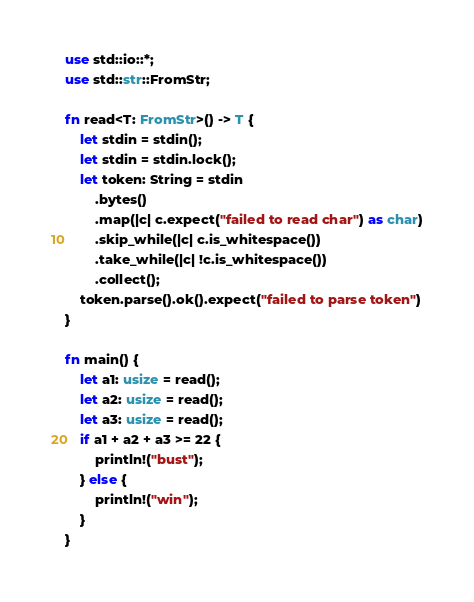Convert code to text. <code><loc_0><loc_0><loc_500><loc_500><_Rust_>use std::io::*;
use std::str::FromStr;

fn read<T: FromStr>() -> T {
    let stdin = stdin();
    let stdin = stdin.lock();
    let token: String = stdin
        .bytes()
        .map(|c| c.expect("failed to read char") as char)
        .skip_while(|c| c.is_whitespace())
        .take_while(|c| !c.is_whitespace())
        .collect();
    token.parse().ok().expect("failed to parse token")
}

fn main() {
    let a1: usize = read();
    let a2: usize = read();
    let a3: usize = read();
    if a1 + a2 + a3 >= 22 {
        println!("bust");
    } else {
        println!("win");
    }
}
</code> 